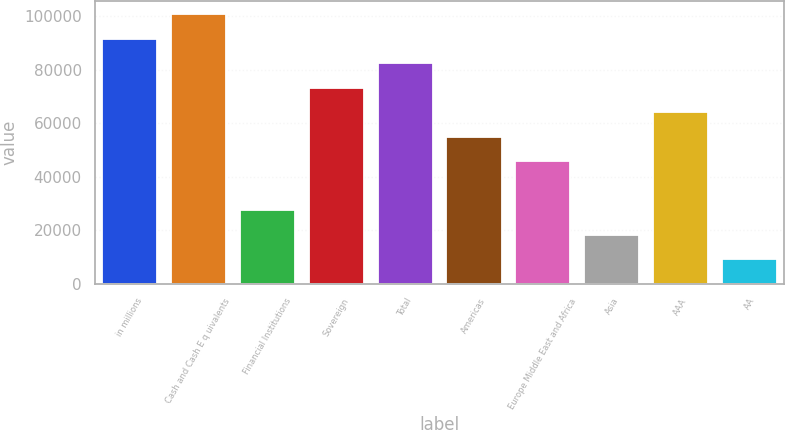Convert chart to OTSL. <chart><loc_0><loc_0><loc_500><loc_500><bar_chart><fcel>in millions<fcel>Cash and Cash E q uivalents<fcel>Financial Institutions<fcel>Sovereign<fcel>Total<fcel>Americas<fcel>Europe Middle East and Africa<fcel>Asia<fcel>AAA<fcel>AA<nl><fcel>91609<fcel>100770<fcel>27483.4<fcel>73287.4<fcel>82448.2<fcel>54965.8<fcel>45805<fcel>18322.6<fcel>64126.6<fcel>9161.8<nl></chart> 